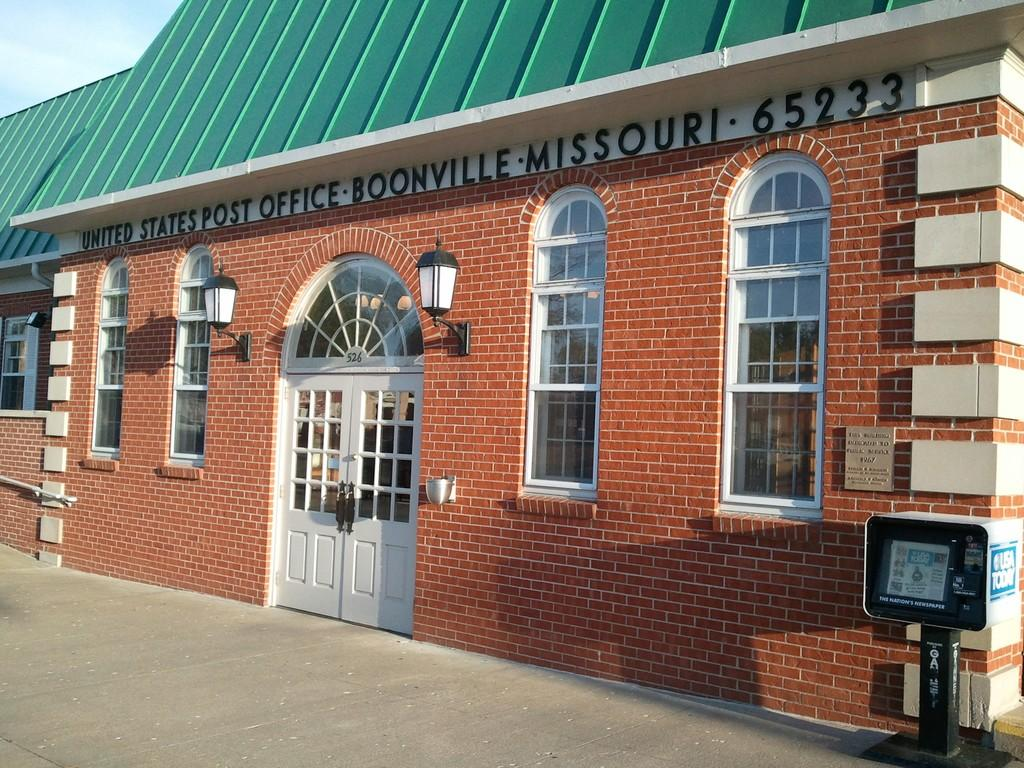What type of structure is present in the image? There is a shed in the image. Where is the meter located in the image? The meter is on the right side of the image. What can be seen in the background of the image? There is sky visible in the background of the image. What type of illumination is present in the image? There are lights in the image. How much growth has the quartz experienced in the image? There is no quartz present in the image, so it is not possible to determine its growth. 